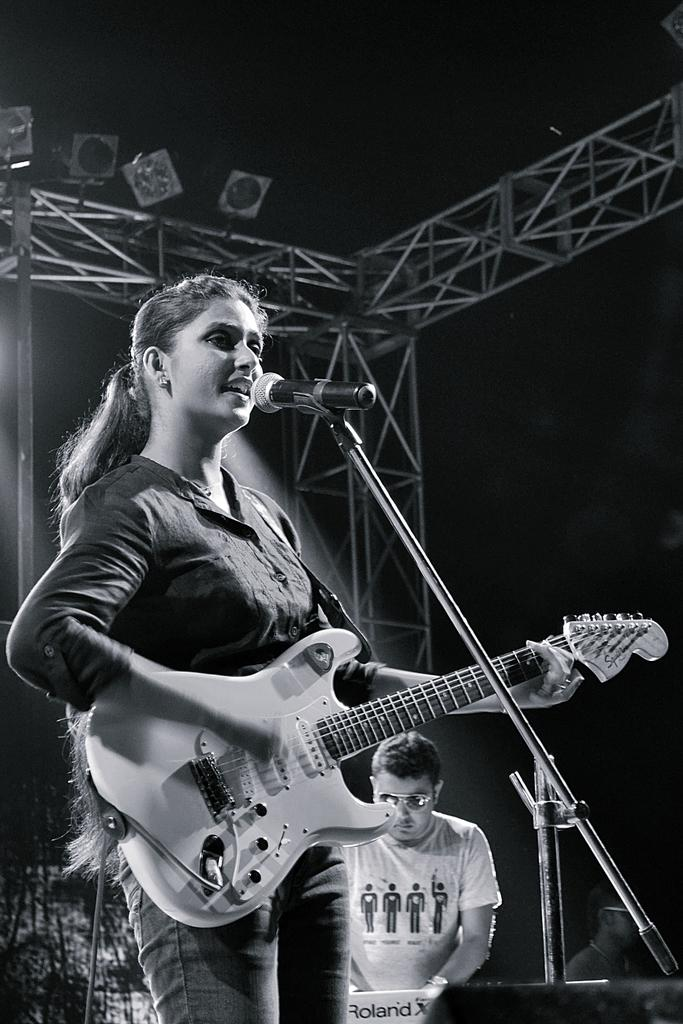What is the main subject of the image? There is a person in the image. What is the person doing in the image? The person is playing a guitar and standing in front of a mic. Can you describe the setting of the image? There is another person visible in the background of the image. What is the price of the appliance being used by the person in the image? There is no appliance mentioned or visible in the image, so it is not possible to determine its price. 